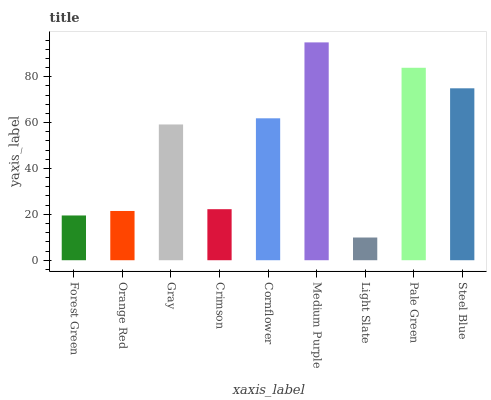Is Light Slate the minimum?
Answer yes or no. Yes. Is Medium Purple the maximum?
Answer yes or no. Yes. Is Orange Red the minimum?
Answer yes or no. No. Is Orange Red the maximum?
Answer yes or no. No. Is Orange Red greater than Forest Green?
Answer yes or no. Yes. Is Forest Green less than Orange Red?
Answer yes or no. Yes. Is Forest Green greater than Orange Red?
Answer yes or no. No. Is Orange Red less than Forest Green?
Answer yes or no. No. Is Gray the high median?
Answer yes or no. Yes. Is Gray the low median?
Answer yes or no. Yes. Is Light Slate the high median?
Answer yes or no. No. Is Crimson the low median?
Answer yes or no. No. 